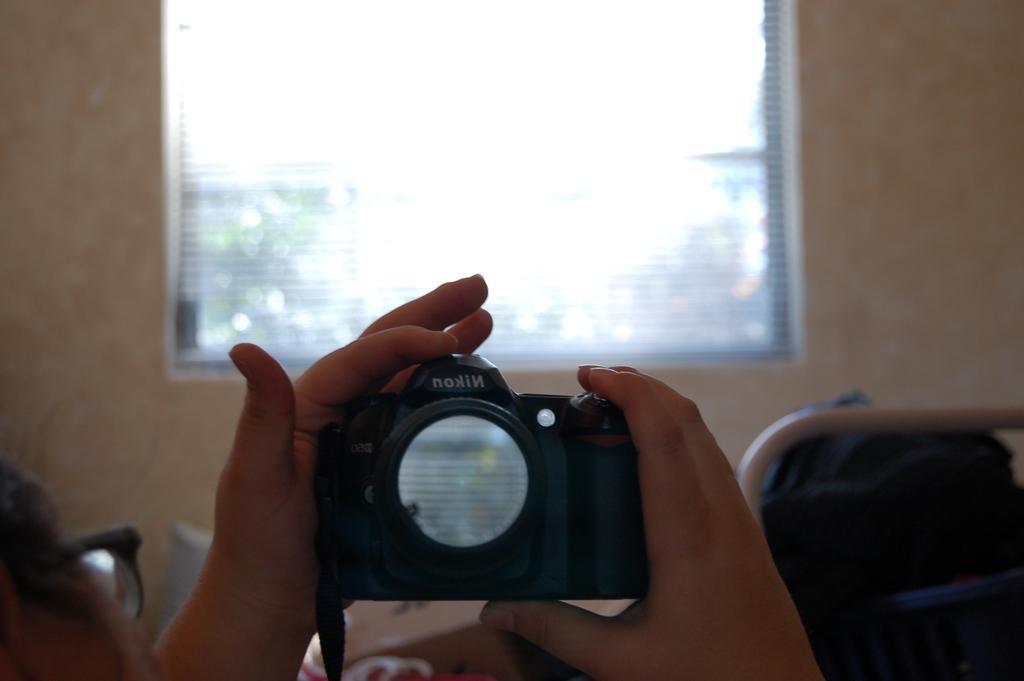Describe this image in one or two sentences. In this image I can see a person wearing spectacles is laying on the bed and holding a camera in his hand. In the background I can see the cream colored wall and the window. 